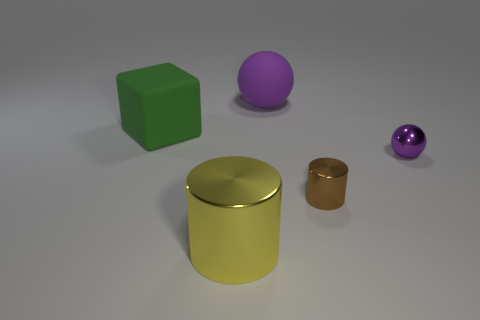Are there an equal number of blue metal cylinders and big rubber balls?
Make the answer very short. No. What size is the purple shiny thing that is the same shape as the large purple rubber object?
Offer a very short reply. Small. How many large blocks are in front of the purple object that is behind the sphere in front of the big green block?
Offer a very short reply. 1. Are there an equal number of big matte balls in front of the large green block and purple metallic balls?
Your answer should be compact. No. How many cylinders are big cyan objects or big yellow objects?
Provide a succinct answer. 1. Is the color of the big ball the same as the small metal cylinder?
Your answer should be compact. No. Are there an equal number of metallic cylinders right of the big purple rubber ball and metallic objects that are on the right side of the tiny brown object?
Your answer should be compact. Yes. What color is the big shiny cylinder?
Offer a terse response. Yellow. How many things are large matte things on the right side of the green cube or red shiny balls?
Make the answer very short. 1. Do the metallic thing right of the small metallic cylinder and the object to the left of the yellow shiny cylinder have the same size?
Offer a terse response. No. 